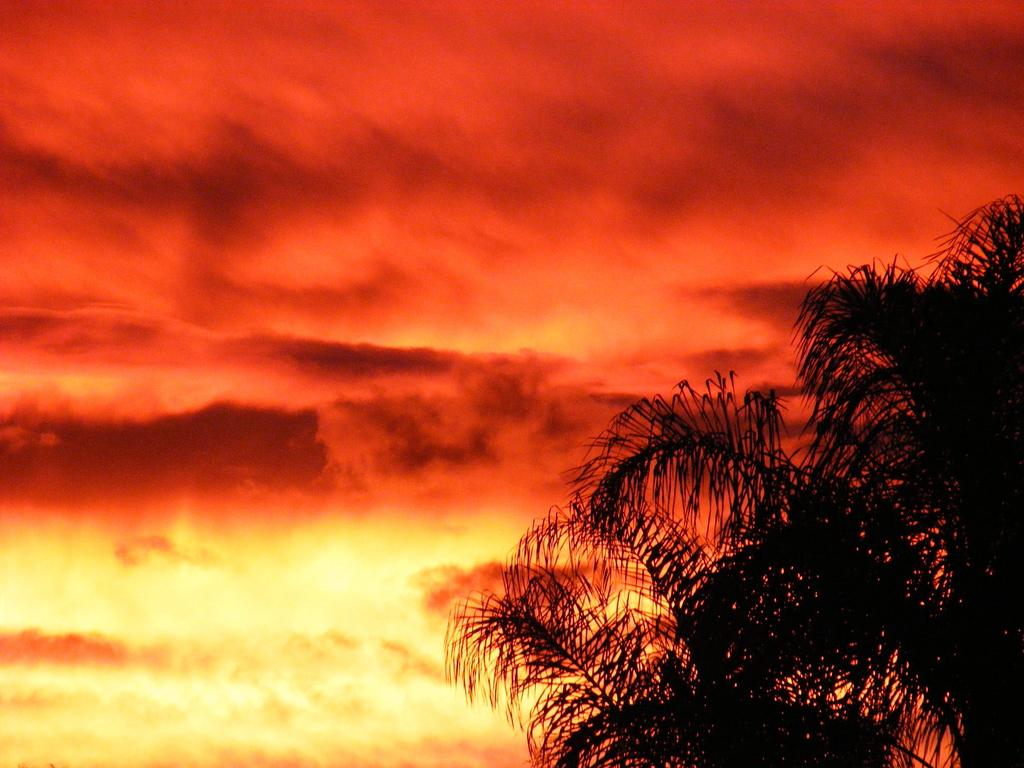What type of vegetation can be seen in the image? There are tree leaves in the image. What is visible in the background of the image? The sky is visible in the image. What can be observed in the sky? Clouds are present in the sky. What type of oatmeal is being served in the image? There is no oatmeal present in the image. Can you read the letter that is being delivered in the image? There is no letter or delivery depicted in the image. 